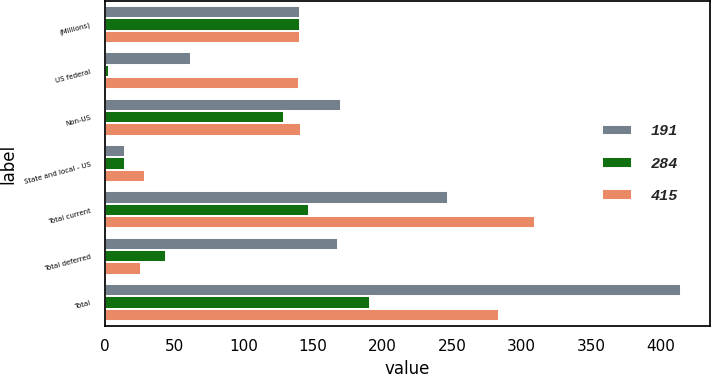<chart> <loc_0><loc_0><loc_500><loc_500><stacked_bar_chart><ecel><fcel>(Millions)<fcel>US federal<fcel>Non-US<fcel>State and local - US<fcel>Total current<fcel>Total deferred<fcel>Total<nl><fcel>191<fcel>140.5<fcel>62<fcel>170<fcel>15<fcel>247<fcel>168<fcel>415<nl><fcel>284<fcel>140.5<fcel>3<fcel>129<fcel>15<fcel>147<fcel>44<fcel>191<nl><fcel>415<fcel>140.5<fcel>140<fcel>141<fcel>29<fcel>310<fcel>26<fcel>284<nl></chart> 